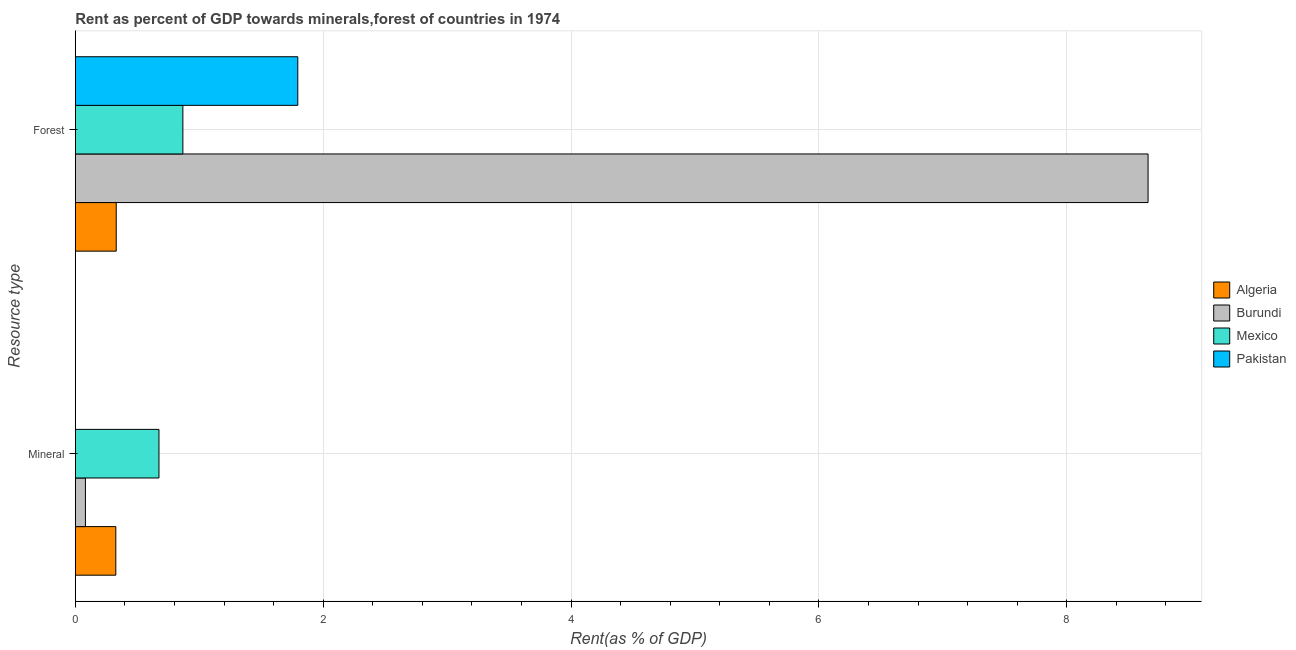How many different coloured bars are there?
Your response must be concise. 4. How many groups of bars are there?
Make the answer very short. 2. Are the number of bars on each tick of the Y-axis equal?
Your response must be concise. Yes. What is the label of the 2nd group of bars from the top?
Your response must be concise. Mineral. What is the mineral rent in Burundi?
Your response must be concise. 0.08. Across all countries, what is the maximum forest rent?
Ensure brevity in your answer.  8.66. Across all countries, what is the minimum forest rent?
Your answer should be compact. 0.33. What is the total mineral rent in the graph?
Offer a very short reply. 1.08. What is the difference between the mineral rent in Mexico and that in Pakistan?
Keep it short and to the point. 0.68. What is the difference between the forest rent in Mexico and the mineral rent in Algeria?
Provide a succinct answer. 0.54. What is the average mineral rent per country?
Provide a short and direct response. 0.27. What is the difference between the forest rent and mineral rent in Pakistan?
Provide a succinct answer. 1.8. In how many countries, is the mineral rent greater than 1.6 %?
Provide a succinct answer. 0. What is the ratio of the mineral rent in Algeria to that in Pakistan?
Your response must be concise. 3821.63. What does the 1st bar from the bottom in Forest represents?
Provide a succinct answer. Algeria. Are all the bars in the graph horizontal?
Give a very brief answer. Yes. How many countries are there in the graph?
Offer a very short reply. 4. What is the difference between two consecutive major ticks on the X-axis?
Give a very brief answer. 2. Are the values on the major ticks of X-axis written in scientific E-notation?
Ensure brevity in your answer.  No. Does the graph contain any zero values?
Provide a short and direct response. No. How many legend labels are there?
Make the answer very short. 4. How are the legend labels stacked?
Ensure brevity in your answer.  Vertical. What is the title of the graph?
Make the answer very short. Rent as percent of GDP towards minerals,forest of countries in 1974. What is the label or title of the X-axis?
Give a very brief answer. Rent(as % of GDP). What is the label or title of the Y-axis?
Provide a short and direct response. Resource type. What is the Rent(as % of GDP) in Algeria in Mineral?
Provide a succinct answer. 0.33. What is the Rent(as % of GDP) in Burundi in Mineral?
Offer a very short reply. 0.08. What is the Rent(as % of GDP) in Mexico in Mineral?
Make the answer very short. 0.68. What is the Rent(as % of GDP) of Pakistan in Mineral?
Your answer should be very brief. 8.55208765846003e-5. What is the Rent(as % of GDP) of Algeria in Forest?
Ensure brevity in your answer.  0.33. What is the Rent(as % of GDP) in Burundi in Forest?
Keep it short and to the point. 8.66. What is the Rent(as % of GDP) in Mexico in Forest?
Your answer should be compact. 0.87. What is the Rent(as % of GDP) in Pakistan in Forest?
Ensure brevity in your answer.  1.8. Across all Resource type, what is the maximum Rent(as % of GDP) of Algeria?
Your response must be concise. 0.33. Across all Resource type, what is the maximum Rent(as % of GDP) of Burundi?
Offer a very short reply. 8.66. Across all Resource type, what is the maximum Rent(as % of GDP) in Mexico?
Provide a short and direct response. 0.87. Across all Resource type, what is the maximum Rent(as % of GDP) in Pakistan?
Provide a short and direct response. 1.8. Across all Resource type, what is the minimum Rent(as % of GDP) in Algeria?
Your answer should be compact. 0.33. Across all Resource type, what is the minimum Rent(as % of GDP) of Burundi?
Provide a succinct answer. 0.08. Across all Resource type, what is the minimum Rent(as % of GDP) in Mexico?
Offer a very short reply. 0.68. Across all Resource type, what is the minimum Rent(as % of GDP) in Pakistan?
Offer a terse response. 8.55208765846003e-5. What is the total Rent(as % of GDP) of Algeria in the graph?
Your answer should be very brief. 0.66. What is the total Rent(as % of GDP) of Burundi in the graph?
Keep it short and to the point. 8.74. What is the total Rent(as % of GDP) of Mexico in the graph?
Offer a terse response. 1.54. What is the total Rent(as % of GDP) of Pakistan in the graph?
Your answer should be very brief. 1.8. What is the difference between the Rent(as % of GDP) in Algeria in Mineral and that in Forest?
Give a very brief answer. -0. What is the difference between the Rent(as % of GDP) of Burundi in Mineral and that in Forest?
Provide a short and direct response. -8.57. What is the difference between the Rent(as % of GDP) of Mexico in Mineral and that in Forest?
Offer a terse response. -0.19. What is the difference between the Rent(as % of GDP) in Pakistan in Mineral and that in Forest?
Keep it short and to the point. -1.8. What is the difference between the Rent(as % of GDP) in Algeria in Mineral and the Rent(as % of GDP) in Burundi in Forest?
Your answer should be very brief. -8.33. What is the difference between the Rent(as % of GDP) in Algeria in Mineral and the Rent(as % of GDP) in Mexico in Forest?
Keep it short and to the point. -0.54. What is the difference between the Rent(as % of GDP) of Algeria in Mineral and the Rent(as % of GDP) of Pakistan in Forest?
Provide a short and direct response. -1.47. What is the difference between the Rent(as % of GDP) of Burundi in Mineral and the Rent(as % of GDP) of Mexico in Forest?
Give a very brief answer. -0.79. What is the difference between the Rent(as % of GDP) in Burundi in Mineral and the Rent(as % of GDP) in Pakistan in Forest?
Keep it short and to the point. -1.71. What is the difference between the Rent(as % of GDP) in Mexico in Mineral and the Rent(as % of GDP) in Pakistan in Forest?
Provide a succinct answer. -1.12. What is the average Rent(as % of GDP) of Algeria per Resource type?
Offer a terse response. 0.33. What is the average Rent(as % of GDP) of Burundi per Resource type?
Ensure brevity in your answer.  4.37. What is the average Rent(as % of GDP) in Mexico per Resource type?
Provide a short and direct response. 0.77. What is the average Rent(as % of GDP) of Pakistan per Resource type?
Provide a succinct answer. 0.9. What is the difference between the Rent(as % of GDP) of Algeria and Rent(as % of GDP) of Burundi in Mineral?
Offer a very short reply. 0.25. What is the difference between the Rent(as % of GDP) in Algeria and Rent(as % of GDP) in Mexico in Mineral?
Your answer should be compact. -0.35. What is the difference between the Rent(as % of GDP) in Algeria and Rent(as % of GDP) in Pakistan in Mineral?
Offer a terse response. 0.33. What is the difference between the Rent(as % of GDP) in Burundi and Rent(as % of GDP) in Mexico in Mineral?
Give a very brief answer. -0.59. What is the difference between the Rent(as % of GDP) in Burundi and Rent(as % of GDP) in Pakistan in Mineral?
Make the answer very short. 0.08. What is the difference between the Rent(as % of GDP) of Mexico and Rent(as % of GDP) of Pakistan in Mineral?
Your answer should be very brief. 0.68. What is the difference between the Rent(as % of GDP) in Algeria and Rent(as % of GDP) in Burundi in Forest?
Offer a terse response. -8.33. What is the difference between the Rent(as % of GDP) in Algeria and Rent(as % of GDP) in Mexico in Forest?
Your response must be concise. -0.54. What is the difference between the Rent(as % of GDP) in Algeria and Rent(as % of GDP) in Pakistan in Forest?
Make the answer very short. -1.47. What is the difference between the Rent(as % of GDP) of Burundi and Rent(as % of GDP) of Mexico in Forest?
Ensure brevity in your answer.  7.79. What is the difference between the Rent(as % of GDP) of Burundi and Rent(as % of GDP) of Pakistan in Forest?
Your answer should be very brief. 6.86. What is the difference between the Rent(as % of GDP) of Mexico and Rent(as % of GDP) of Pakistan in Forest?
Your answer should be compact. -0.93. What is the ratio of the Rent(as % of GDP) of Burundi in Mineral to that in Forest?
Provide a succinct answer. 0.01. What is the ratio of the Rent(as % of GDP) in Mexico in Mineral to that in Forest?
Offer a terse response. 0.78. What is the ratio of the Rent(as % of GDP) in Pakistan in Mineral to that in Forest?
Provide a short and direct response. 0. What is the difference between the highest and the second highest Rent(as % of GDP) in Algeria?
Offer a terse response. 0. What is the difference between the highest and the second highest Rent(as % of GDP) of Burundi?
Keep it short and to the point. 8.57. What is the difference between the highest and the second highest Rent(as % of GDP) in Mexico?
Keep it short and to the point. 0.19. What is the difference between the highest and the second highest Rent(as % of GDP) of Pakistan?
Your answer should be very brief. 1.8. What is the difference between the highest and the lowest Rent(as % of GDP) in Algeria?
Ensure brevity in your answer.  0. What is the difference between the highest and the lowest Rent(as % of GDP) of Burundi?
Your response must be concise. 8.57. What is the difference between the highest and the lowest Rent(as % of GDP) in Mexico?
Provide a short and direct response. 0.19. What is the difference between the highest and the lowest Rent(as % of GDP) in Pakistan?
Keep it short and to the point. 1.8. 